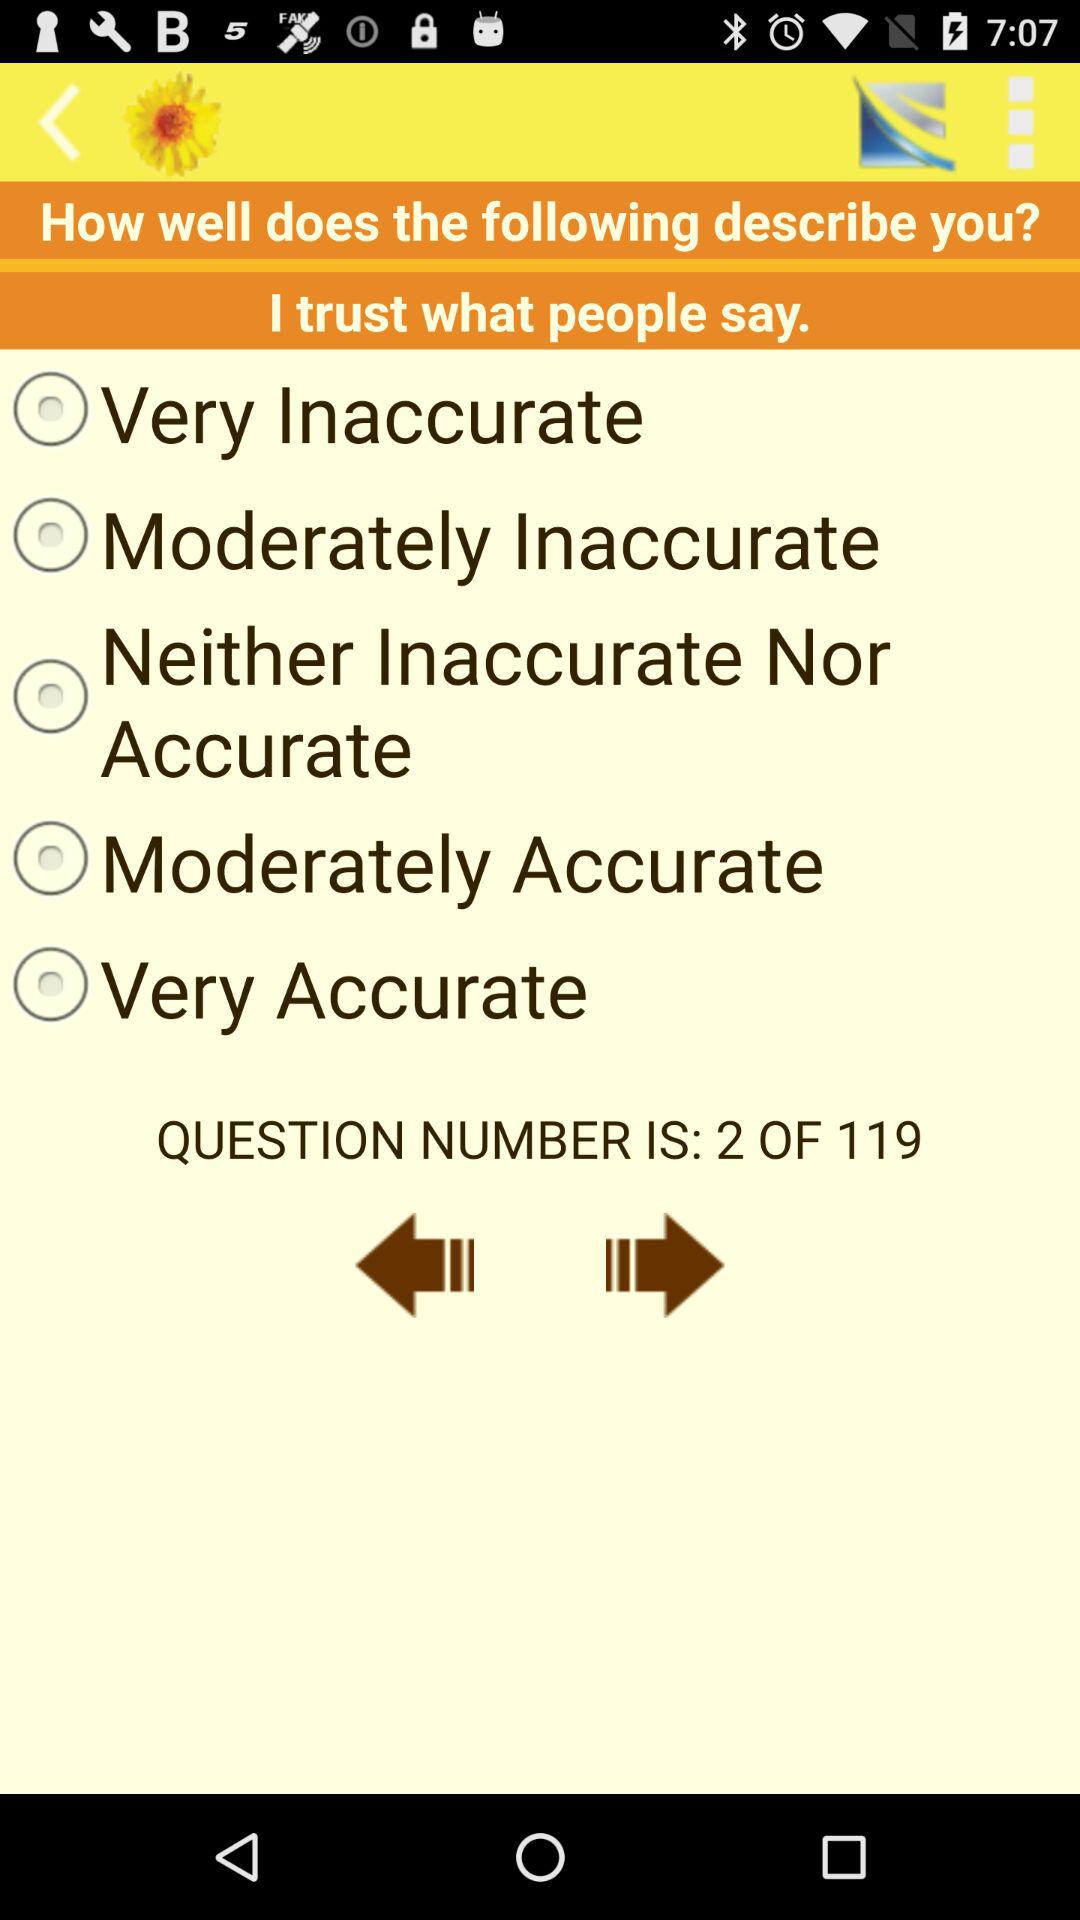I am at what question number? You are at question number 2. 